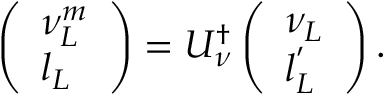Convert formula to latex. <formula><loc_0><loc_0><loc_500><loc_500>\left ( \begin{array} { l } { { \nu _ { L } ^ { m } } } \\ { { l _ { L } } } \end{array} \right ) = U _ { \nu } ^ { \dagger } \left ( \begin{array} { l } { { \nu _ { L } } } \\ { { l _ { L } ^ { ^ { \prime } } } } \end{array} \right ) .</formula> 